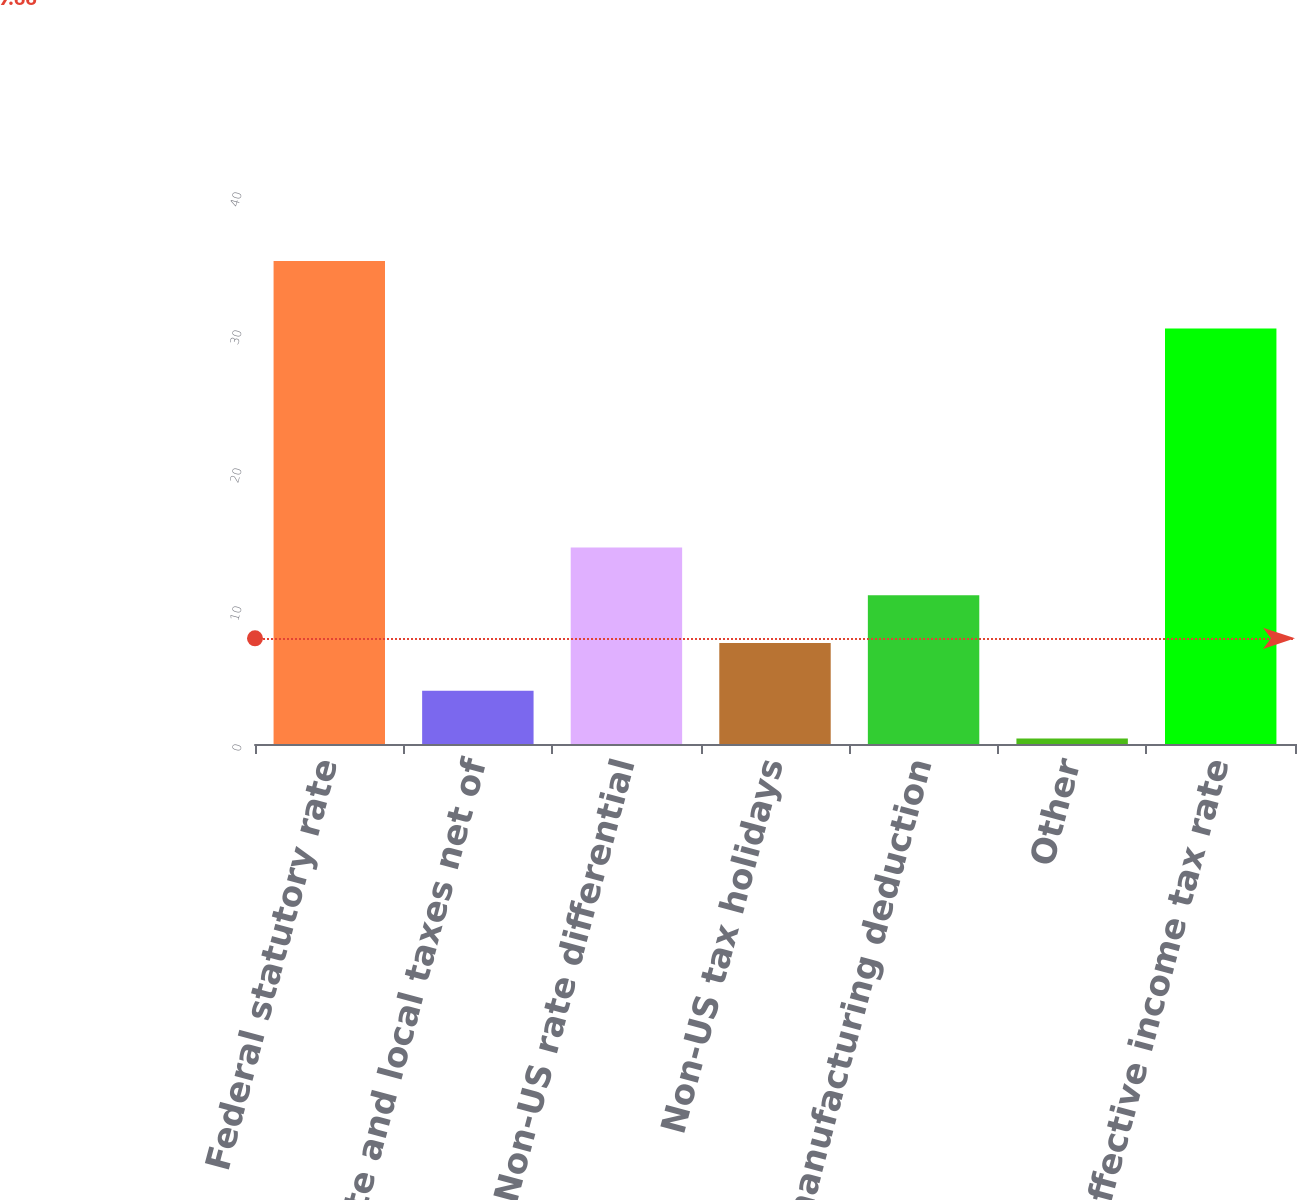Convert chart to OTSL. <chart><loc_0><loc_0><loc_500><loc_500><bar_chart><fcel>Federal statutory rate<fcel>State and local taxes net of<fcel>Non-US rate differential<fcel>Non-US tax holidays<fcel>US manufacturing deduction<fcel>Other<fcel>Effective income tax rate<nl><fcel>35<fcel>3.86<fcel>14.24<fcel>7.32<fcel>10.78<fcel>0.4<fcel>30.1<nl></chart> 